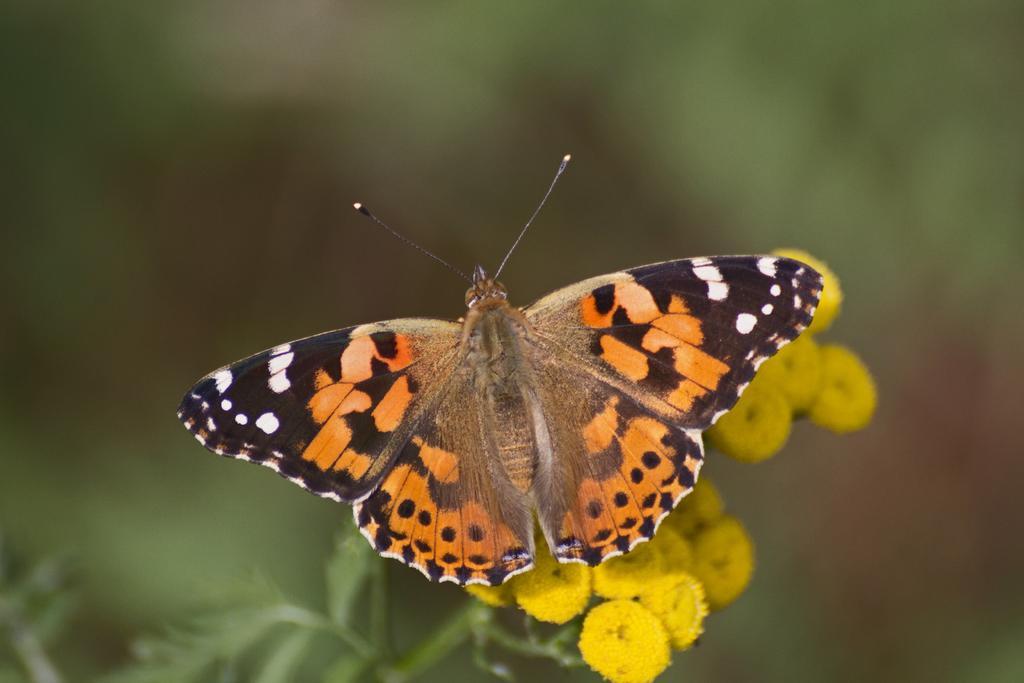Please provide a concise description of this image. In the picture I can see a butterfly and flower plant. These flowers are yellow in color. The background of the image is blurred. 